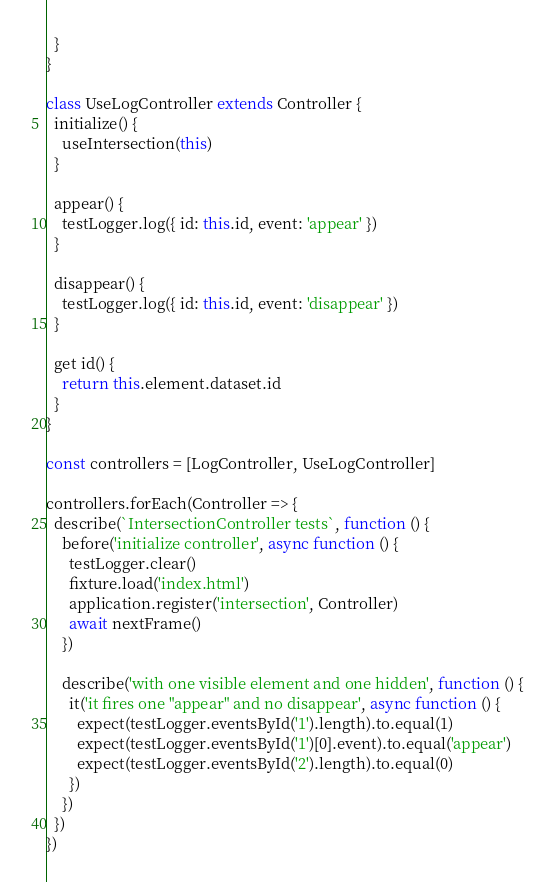Convert code to text. <code><loc_0><loc_0><loc_500><loc_500><_JavaScript_>  }
}

class UseLogController extends Controller {
  initialize() {
    useIntersection(this)
  }

  appear() {
    testLogger.log({ id: this.id, event: 'appear' })
  }

  disappear() {
    testLogger.log({ id: this.id, event: 'disappear' })
  }

  get id() {
    return this.element.dataset.id
  }
}

const controllers = [LogController, UseLogController]

controllers.forEach(Controller => {
  describe(`IntersectionController tests`, function () {
    before('initialize controller', async function () {
      testLogger.clear()
      fixture.load('index.html')
      application.register('intersection', Controller)
      await nextFrame()
    })

    describe('with one visible element and one hidden', function () {
      it('it fires one "appear" and no disappear', async function () {
        expect(testLogger.eventsById('1').length).to.equal(1)
        expect(testLogger.eventsById('1')[0].event).to.equal('appear')
        expect(testLogger.eventsById('2').length).to.equal(0)
      })
    })
  })
})
</code> 